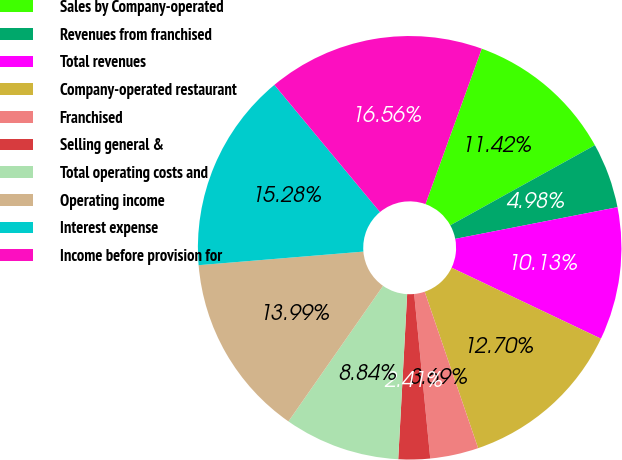Convert chart. <chart><loc_0><loc_0><loc_500><loc_500><pie_chart><fcel>Sales by Company-operated<fcel>Revenues from franchised<fcel>Total revenues<fcel>Company-operated restaurant<fcel>Franchised<fcel>Selling general &<fcel>Total operating costs and<fcel>Operating income<fcel>Interest expense<fcel>Income before provision for<nl><fcel>11.42%<fcel>4.98%<fcel>10.13%<fcel>12.7%<fcel>3.69%<fcel>2.41%<fcel>8.84%<fcel>13.99%<fcel>15.28%<fcel>16.56%<nl></chart> 